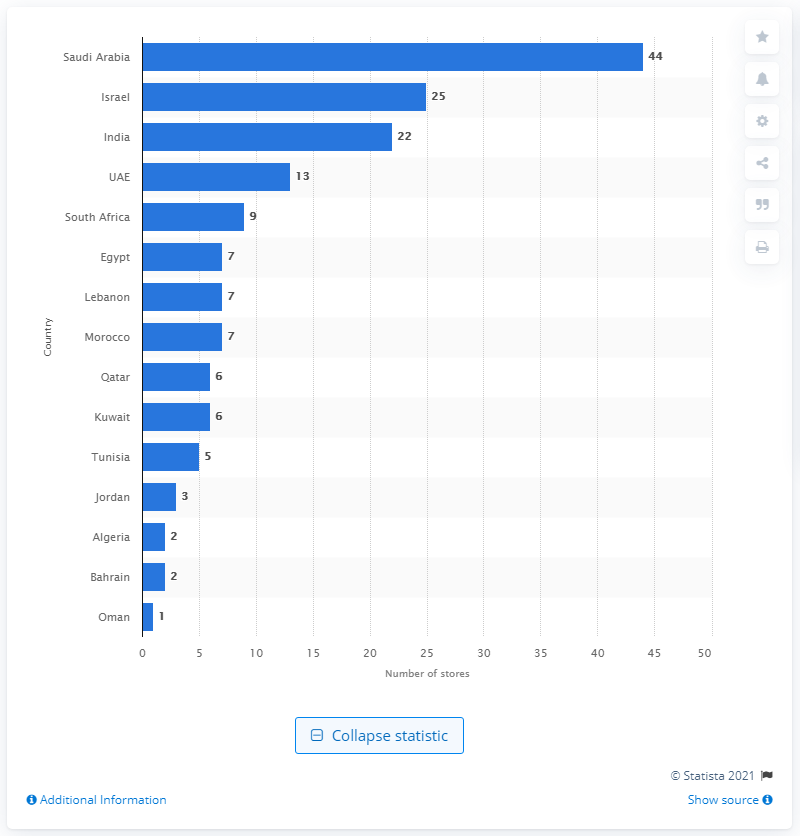Draw attention to some important aspects in this diagram. As of January 31, 2020, there were 13 Zara stores operating in the United Arab Emirates. 